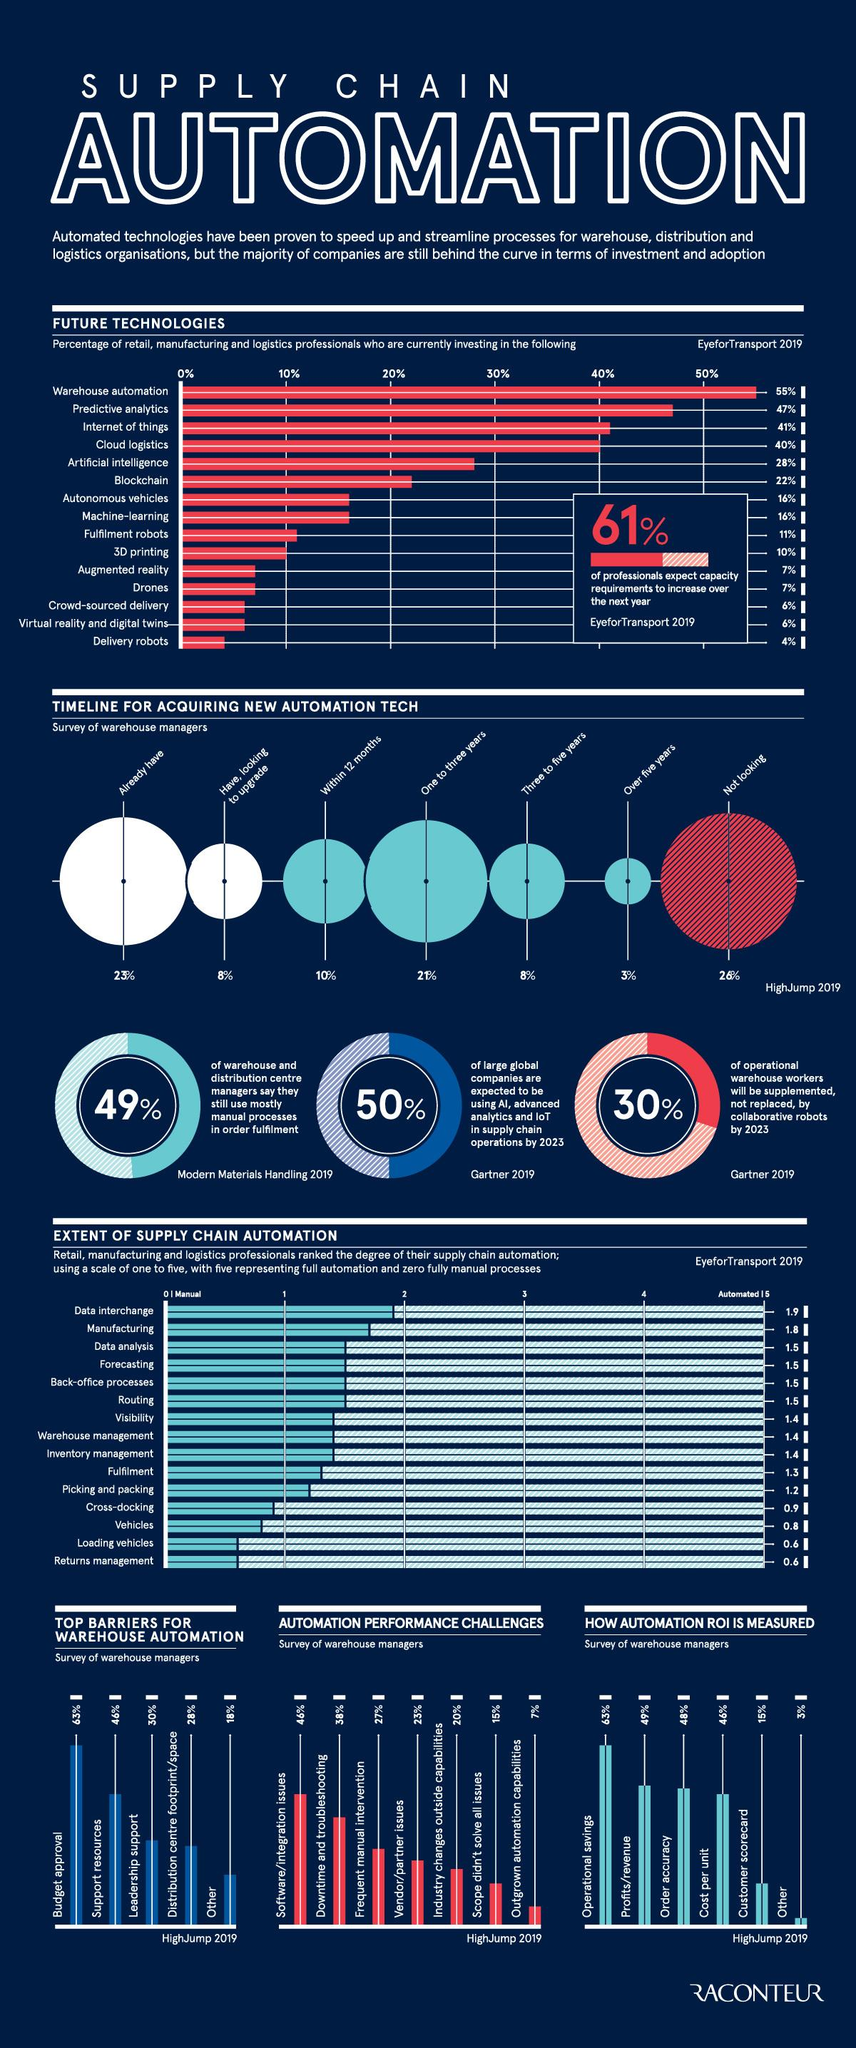Specify some key components in this picture. The ranking of the second position when calculating the return on investment (ROI) of automation is determined by profits or revenue. Thirty-nine percent of professionals plan to update to automation technologies within the next five years. According to a recent survey, 77% of professionals have not yet adopted the latest automation technologies. According to the survey, only 3% of professionals have no plans to update to automation technologies within the next 5 years. According to the ranking, the Internet of Things is the technology that placed third among other future technologies. 